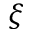Convert formula to latex. <formula><loc_0><loc_0><loc_500><loc_500>\xi</formula> 